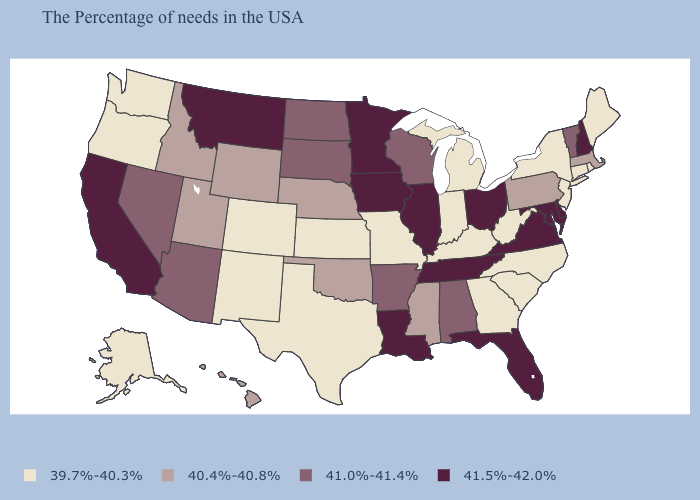Name the states that have a value in the range 41.0%-41.4%?
Concise answer only. Vermont, Alabama, Wisconsin, Arkansas, South Dakota, North Dakota, Arizona, Nevada. Does Alabama have a lower value than New Hampshire?
Be succinct. Yes. What is the value of Arizona?
Keep it brief. 41.0%-41.4%. What is the value of New Mexico?
Keep it brief. 39.7%-40.3%. How many symbols are there in the legend?
Concise answer only. 4. What is the highest value in the West ?
Short answer required. 41.5%-42.0%. Name the states that have a value in the range 41.5%-42.0%?
Keep it brief. New Hampshire, Delaware, Maryland, Virginia, Ohio, Florida, Tennessee, Illinois, Louisiana, Minnesota, Iowa, Montana, California. Among the states that border Utah , does Arizona have the highest value?
Be succinct. Yes. Name the states that have a value in the range 39.7%-40.3%?
Quick response, please. Maine, Rhode Island, Connecticut, New York, New Jersey, North Carolina, South Carolina, West Virginia, Georgia, Michigan, Kentucky, Indiana, Missouri, Kansas, Texas, Colorado, New Mexico, Washington, Oregon, Alaska. Name the states that have a value in the range 41.0%-41.4%?
Answer briefly. Vermont, Alabama, Wisconsin, Arkansas, South Dakota, North Dakota, Arizona, Nevada. What is the value of Texas?
Answer briefly. 39.7%-40.3%. Name the states that have a value in the range 41.0%-41.4%?
Be succinct. Vermont, Alabama, Wisconsin, Arkansas, South Dakota, North Dakota, Arizona, Nevada. What is the value of New Hampshire?
Write a very short answer. 41.5%-42.0%. Which states have the lowest value in the Northeast?
Answer briefly. Maine, Rhode Island, Connecticut, New York, New Jersey. Is the legend a continuous bar?
Answer briefly. No. 